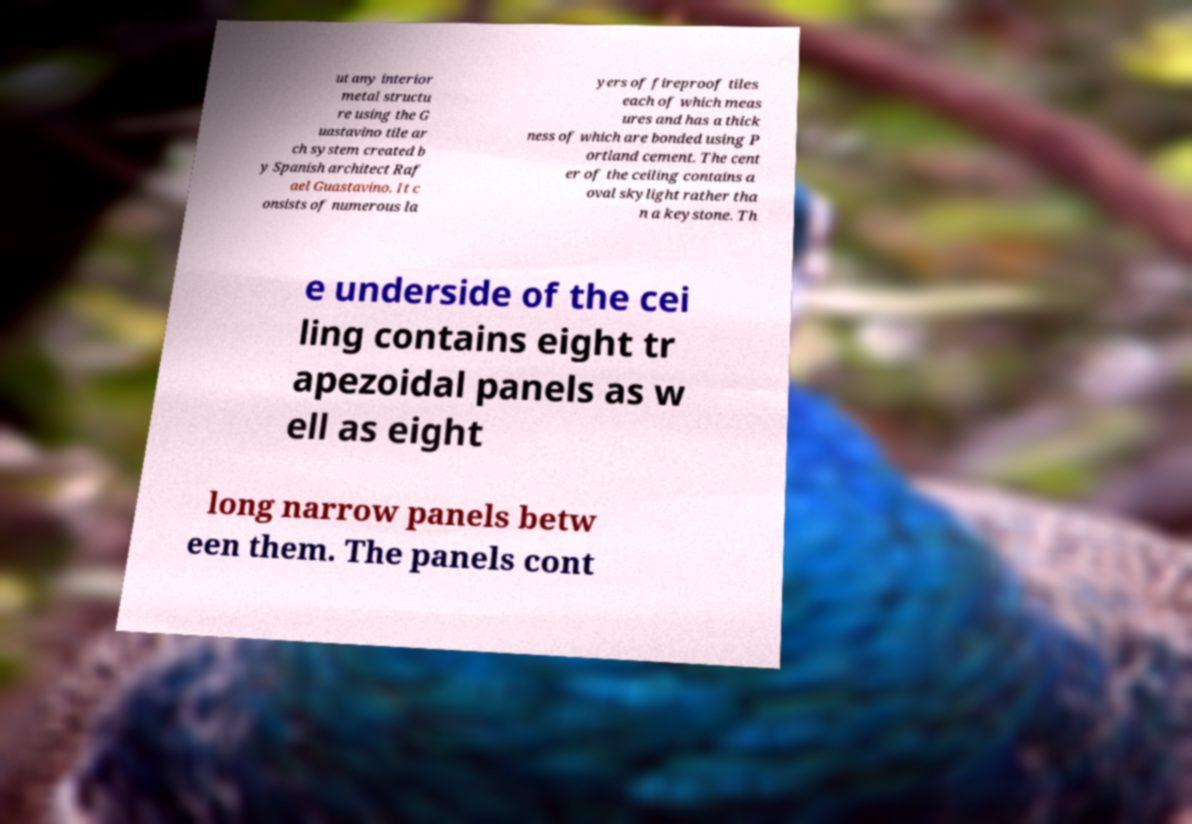Can you read and provide the text displayed in the image?This photo seems to have some interesting text. Can you extract and type it out for me? ut any interior metal structu re using the G uastavino tile ar ch system created b y Spanish architect Raf ael Guastavino. It c onsists of numerous la yers of fireproof tiles each of which meas ures and has a thick ness of which are bonded using P ortland cement. The cent er of the ceiling contains a oval skylight rather tha n a keystone. Th e underside of the cei ling contains eight tr apezoidal panels as w ell as eight long narrow panels betw een them. The panels cont 